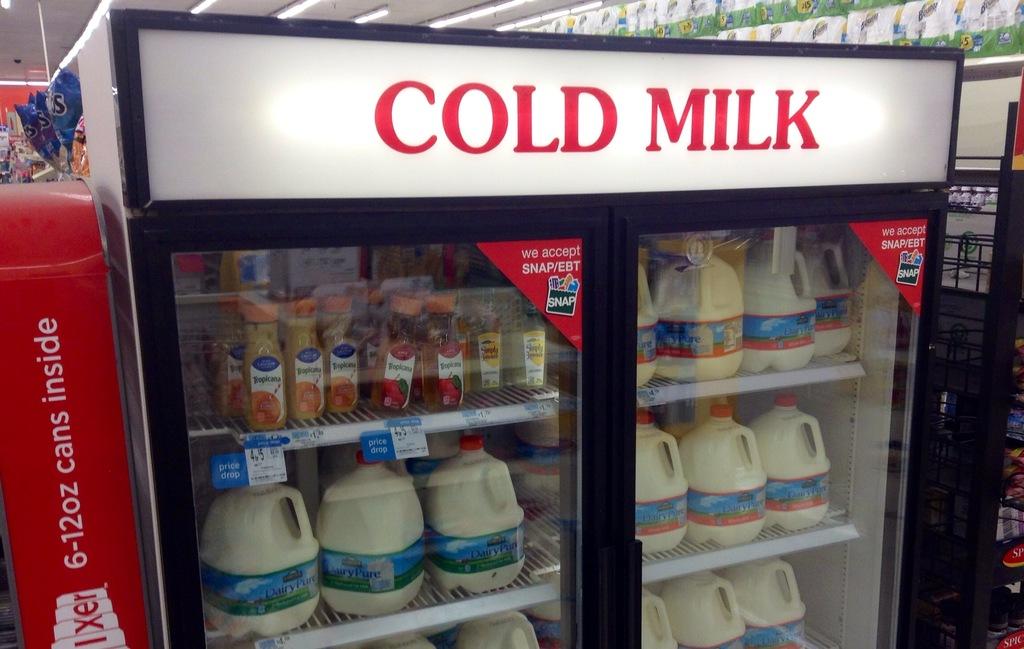What cold beverage is on sale here?
Keep it short and to the point. Milk. 